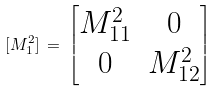Convert formula to latex. <formula><loc_0><loc_0><loc_500><loc_500>[ M ^ { 2 } _ { 1 } ] \, = \, \begin{bmatrix} M ^ { 2 } _ { 1 1 } & 0 \\ 0 & M ^ { 2 } _ { 1 2 } \end{bmatrix}</formula> 